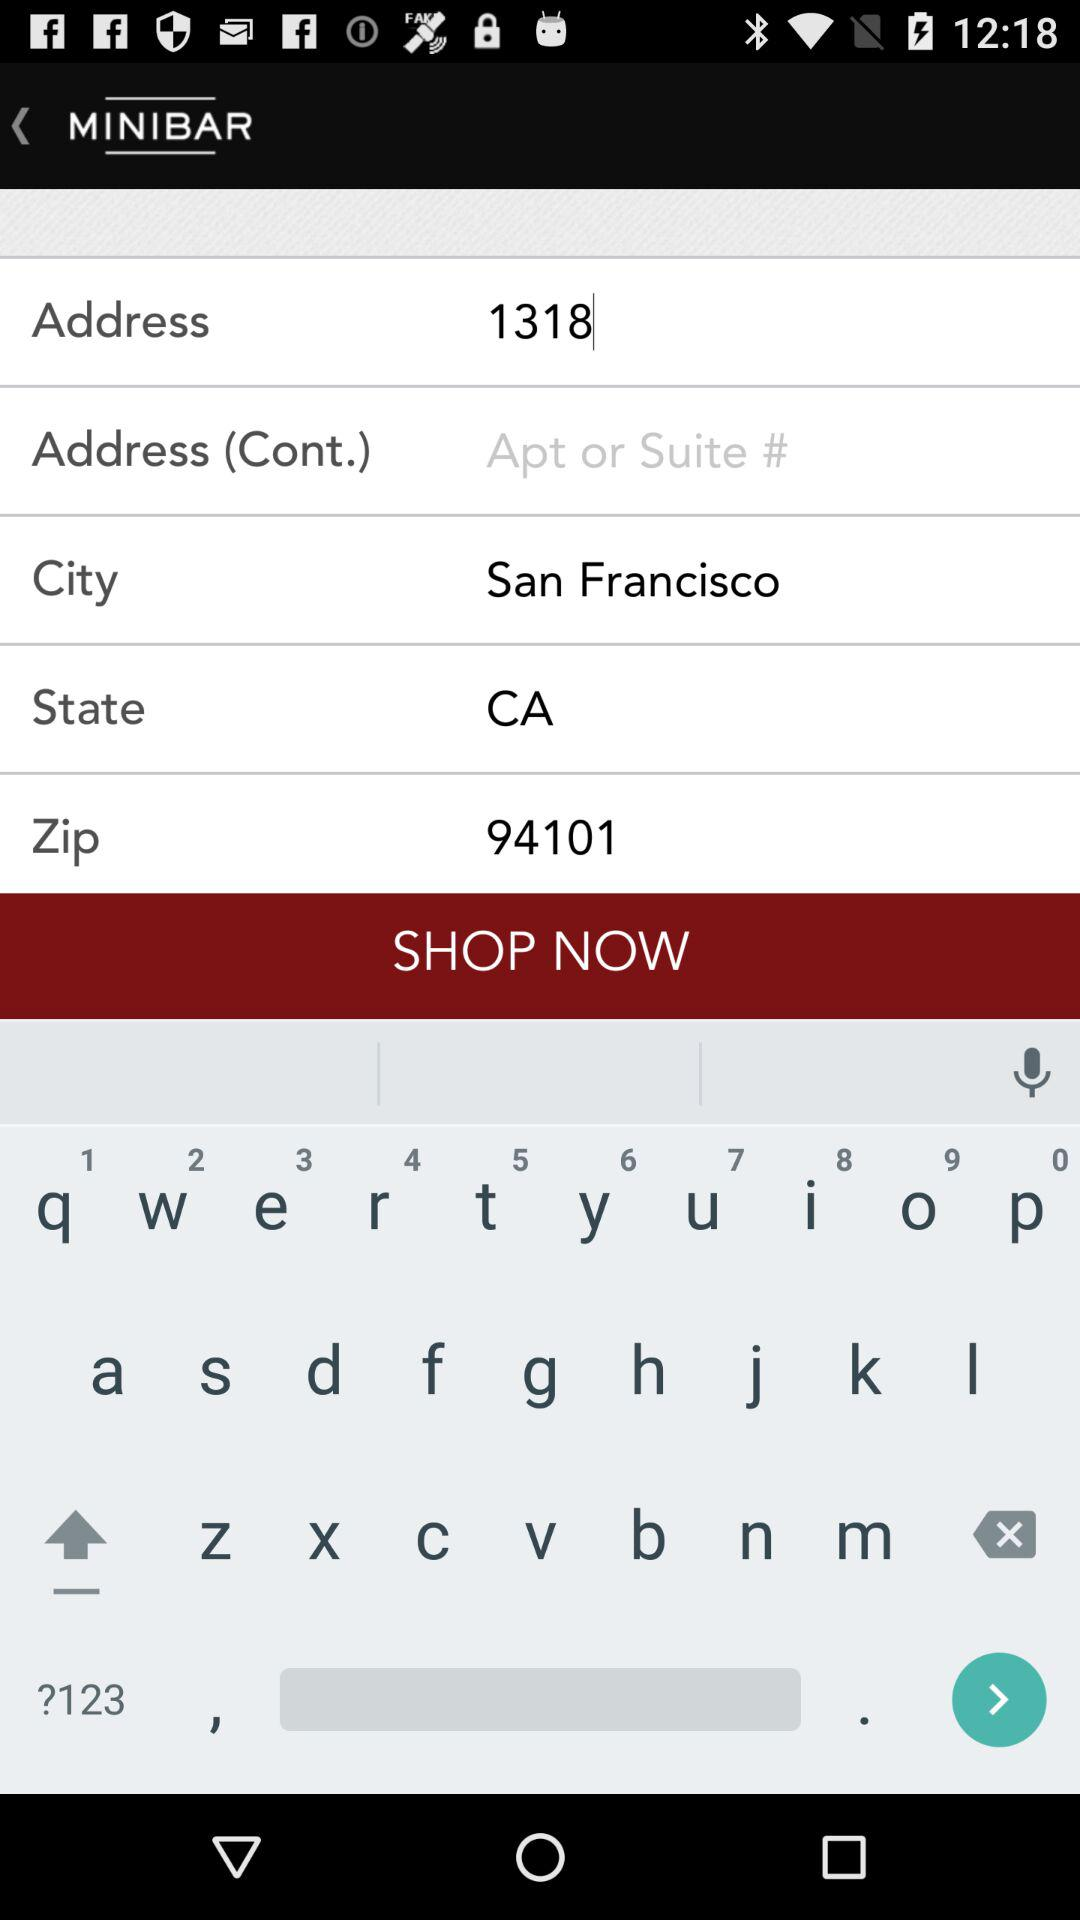What is the mentioned city? The mentioned city is San Francisco. 